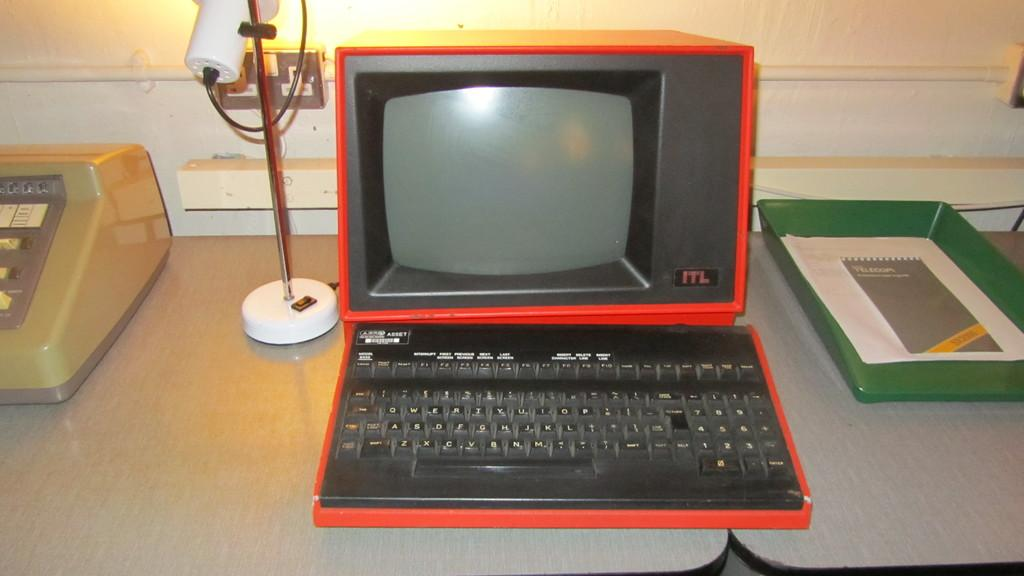<image>
Summarize the visual content of the image. A red and black computer has ITL in the right hand corner of the monitor. 